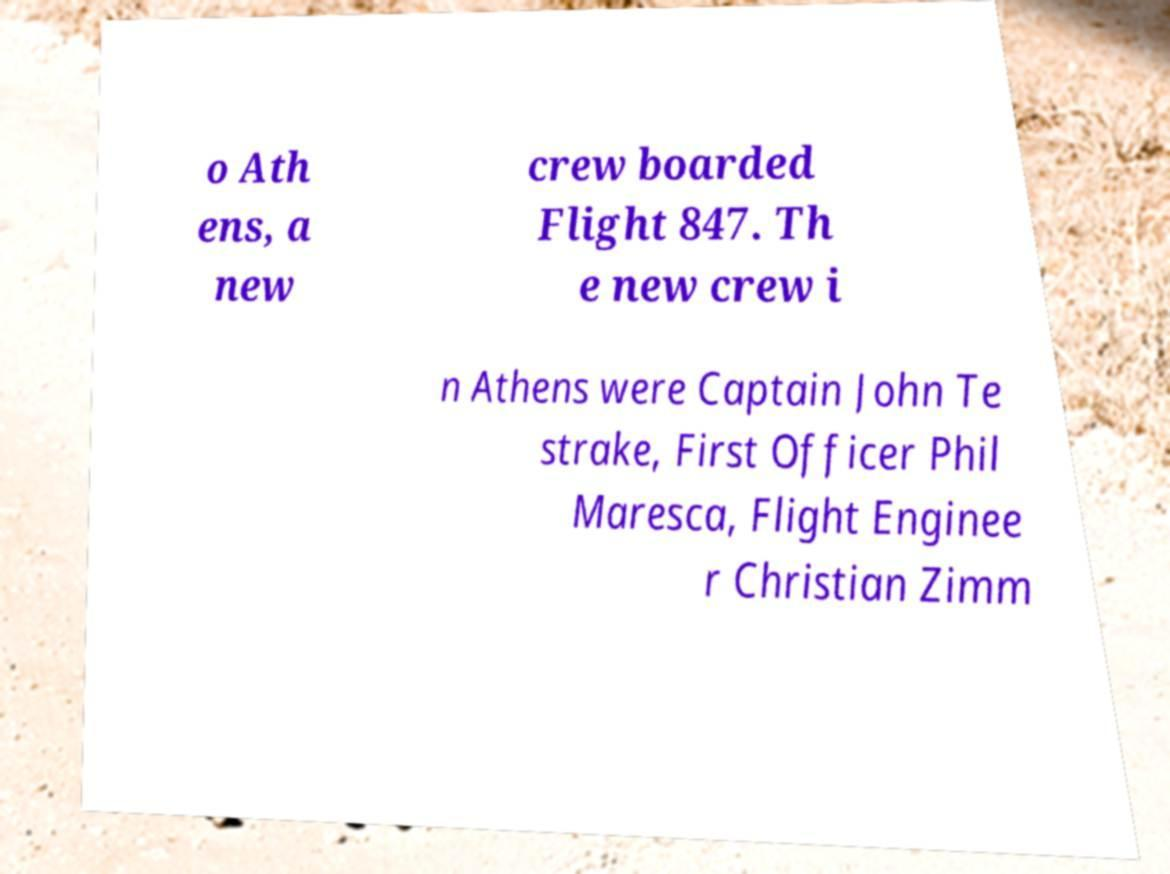Please identify and transcribe the text found in this image. o Ath ens, a new crew boarded Flight 847. Th e new crew i n Athens were Captain John Te strake, First Officer Phil Maresca, Flight Enginee r Christian Zimm 